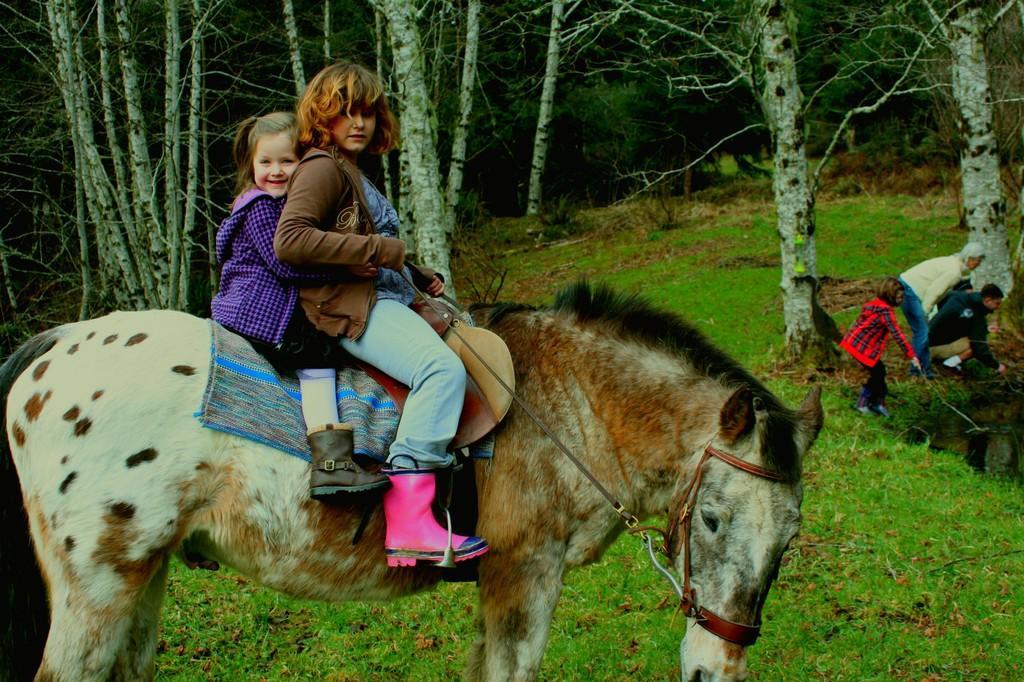Please provide a concise description of this image. In this image, we can see people wearing shoes and sitting on the donkey and holding a rope. In the background, there are some other people and there are trees. At the bottom, there is ground covered with grass. 